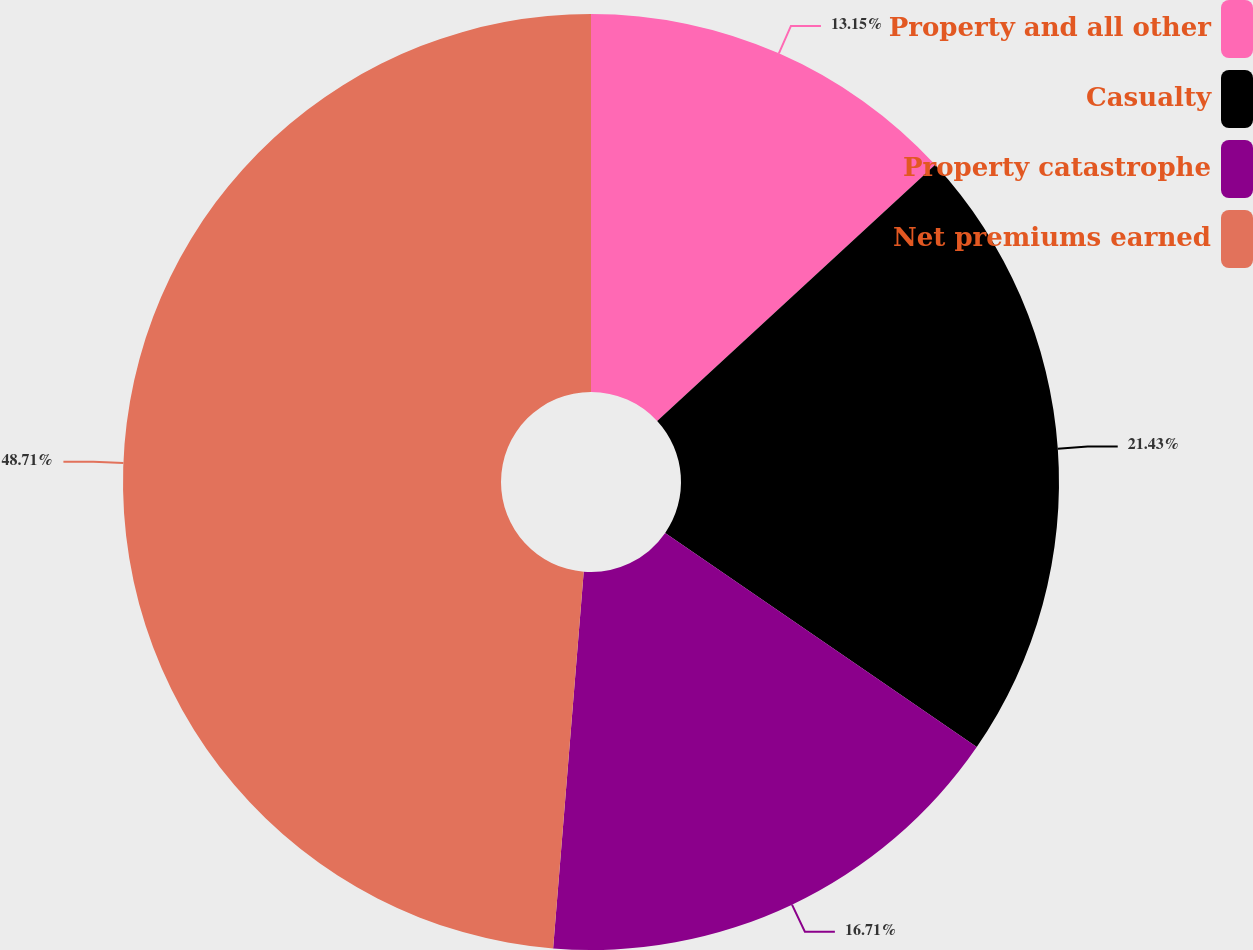<chart> <loc_0><loc_0><loc_500><loc_500><pie_chart><fcel>Property and all other<fcel>Casualty<fcel>Property catastrophe<fcel>Net premiums earned<nl><fcel>13.15%<fcel>21.43%<fcel>16.71%<fcel>48.71%<nl></chart> 